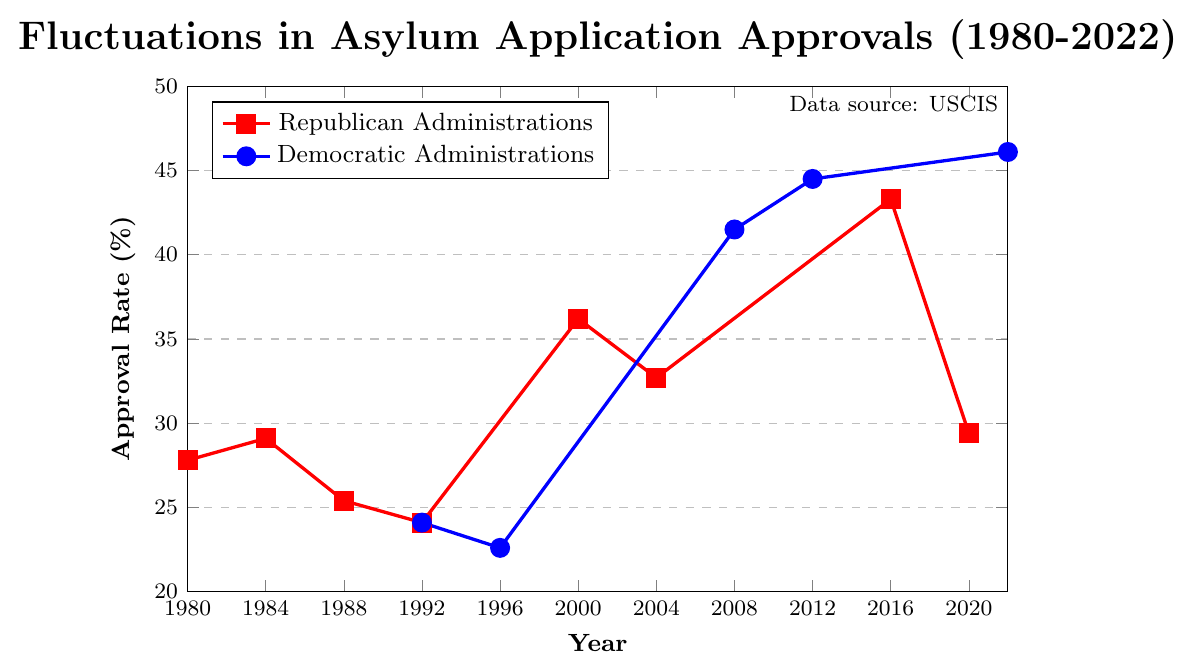what trend can be observed in Republican administrations from 1980 to 2020? The approval rates show fluctuations with an initial increase from 27.8% in 1980 to 29.1% in 1984, a decrease to 24.1% in 1992, followed by a significant increase to 36.2% in 2000, a slight drop to 32.7% in 2004, another rise to 43.3% in 2016, and finally a sharp decrease to 29.4% in 2020.
Answer: Fluctuations with an overall slight decline Which administration saw the highest approval rate between 1980-2022? The highest approval rate was under the Democratic administration in 2022, reaching 46.1%.
Answer: 46.1% Considering all data points, which year had the lowest approval rate, and what was the percentage? The year 1996, during a Democratic administration, had the lowest approval rate at 22.6%.
Answer: 1996, 22.6% What is the average approval rate for Democratic administrations from 1996 to 2022? Calculating the average involves adding the approval rates for Democratic administrations: 22.6 (1996), 41.5 (2008), 44.5 (2012), and 46.1 (2022) which totals to 154.7. Dividing by the 4 data points: 154.7 / 4 = 38.675.
Answer: 38.675% How did the approval rate change from the last Republican administration in 2020 to the following Democratic administration in 2022? The approval rate increased from 29.4% in 2020 to 46.1% in 2022. The change is calculated by subtracting 29.4 from 46.1, which equals a 16.7% increase.
Answer: Increased by 16.7% During which period under Republican administrations was there a clear increase in the approval rate and by how much? There was a clear increase from 24.1% in 1992 to 36.2% in 2000. The increase is 36.2% - 24.1% which equals 12.1%.
Answer: 1992 to 2000, by 12.1% What is the difference in approval rates between the Republican and Democratic administrations in 1992? Both Republican and Democratic administrations in 1992 had the same approval rate of 24.1%.
Answer: 0% Which administration experienced the most significant decrease in approval rate and over what period? The Republican administration experienced the most significant decrease from 43.3% in 2016 to 29.4% in 2020, resulting in a decrease of 13.9%.
Answer: Republican, 2016 to 2020 How many years did it take for the approval rate to recover under Democratic administrations after reaching its lowest point? From its lowest point in 1996 (22.6%), it took until 2008 (41.5%) for the approval rate to significantly recover. So, it took 12 years.
Answer: 12 years What is the median approval rate for Republican administrations from 1980 to 2020? Ordering the rates: 24.1, 25.4, 27.8, 29.1, 29.4, 32.7, 36.2, 43.3. The median is the average of the two middle numbers, 29.1 and 29.4: (29.1 + 29.4) / 2 = 29.25.
Answer: 29.25 